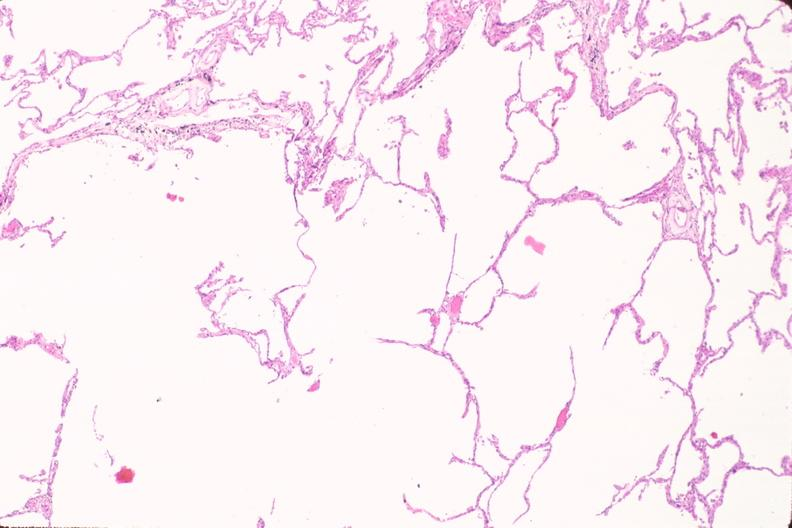s respiratory present?
Answer the question using a single word or phrase. Yes 